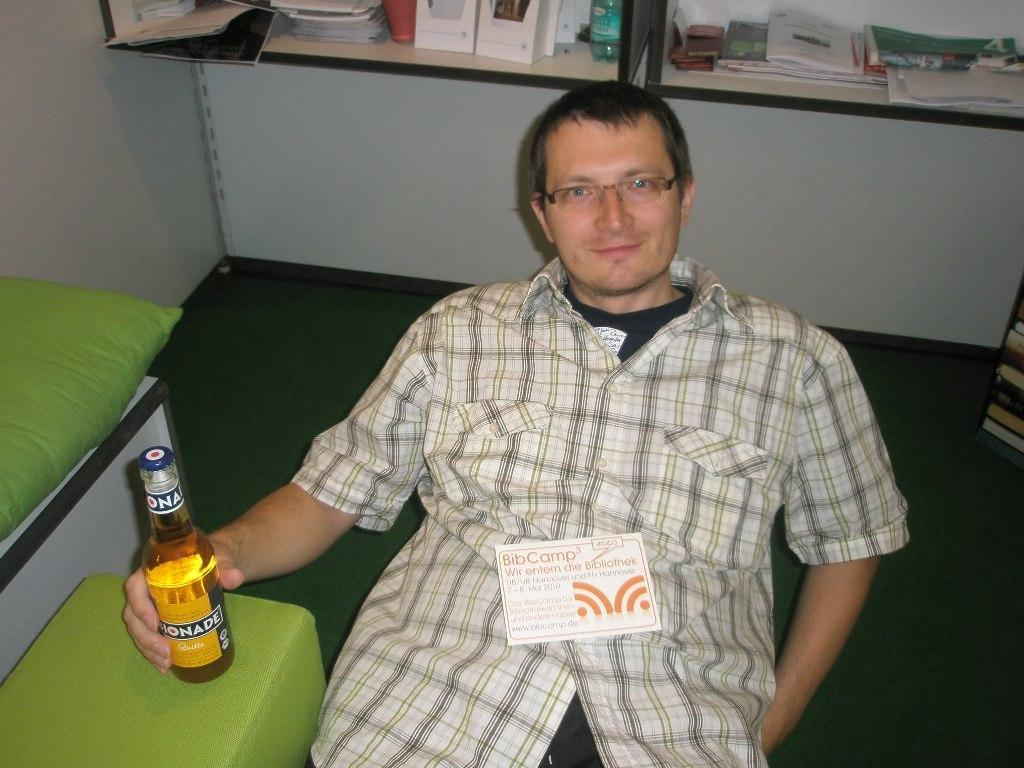Who is the main subject in the image? There is a man in the middle of the image. What is the man doing in the image? The man is catching a bottle in the image. What is the man wearing in the image? The man is wearing a shirt in the image. What is the man's facial expression in the image? The man is smiling in the image. What can be seen in the background of the image? There are shelves in the background of the image. How many items are on the shelves in the image? There are many items on the shelves in the image. What type of star can be seen falling from the sky in the image? There is no star or falling object visible in the image; it only features a man catching a bottle. Is there a crate present in the image? No, there is no crate present in the image. 